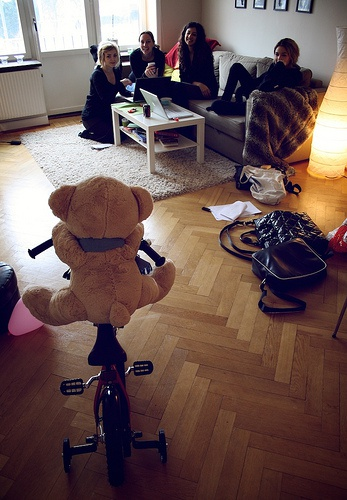Describe the objects in this image and their specific colors. I can see teddy bear in white, maroon, brown, and black tones, couch in white, black, maroon, gray, and darkgray tones, bicycle in white, black, maroon, gray, and brown tones, handbag in white, black, maroon, gray, and navy tones, and people in white, black, gray, maroon, and darkgray tones in this image. 